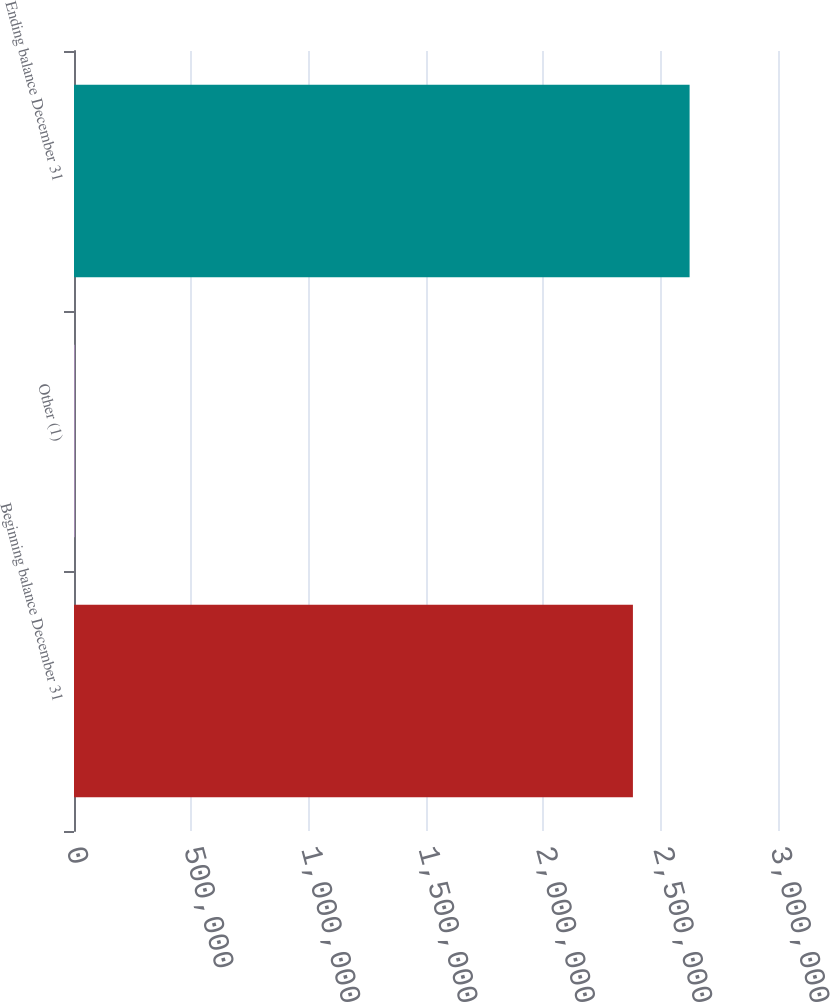Convert chart. <chart><loc_0><loc_0><loc_500><loc_500><bar_chart><fcel>Beginning balance December 31<fcel>Other (1)<fcel>Ending balance December 31<nl><fcel>2.38177e+06<fcel>2447<fcel>2.62329e+06<nl></chart> 